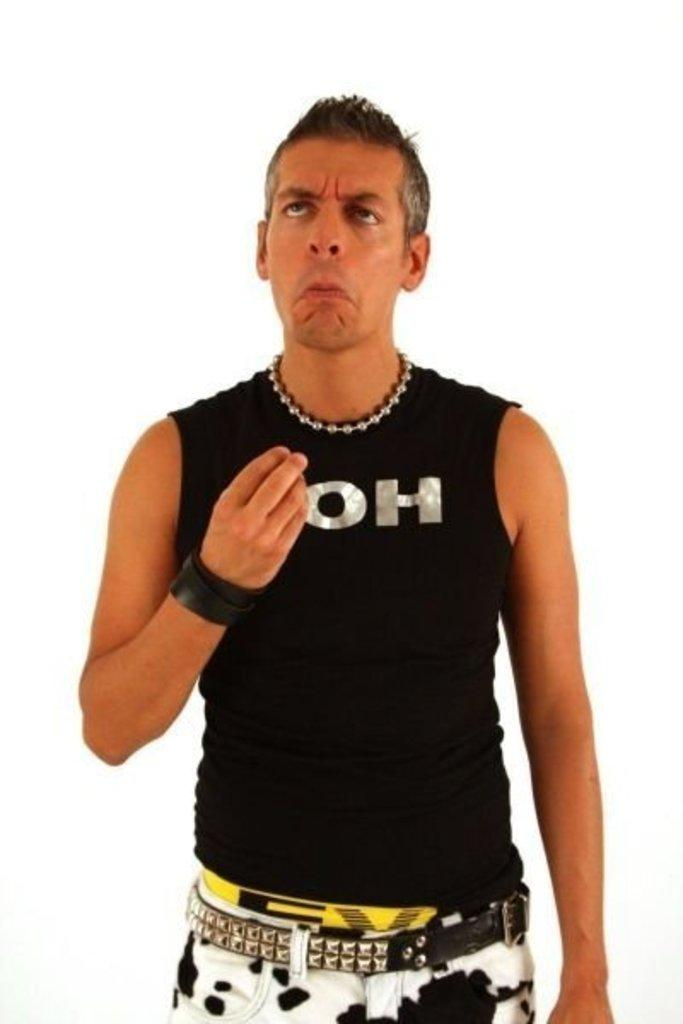<image>
Describe the image concisely. A man wearing a black tank top with the word OH on the front. 